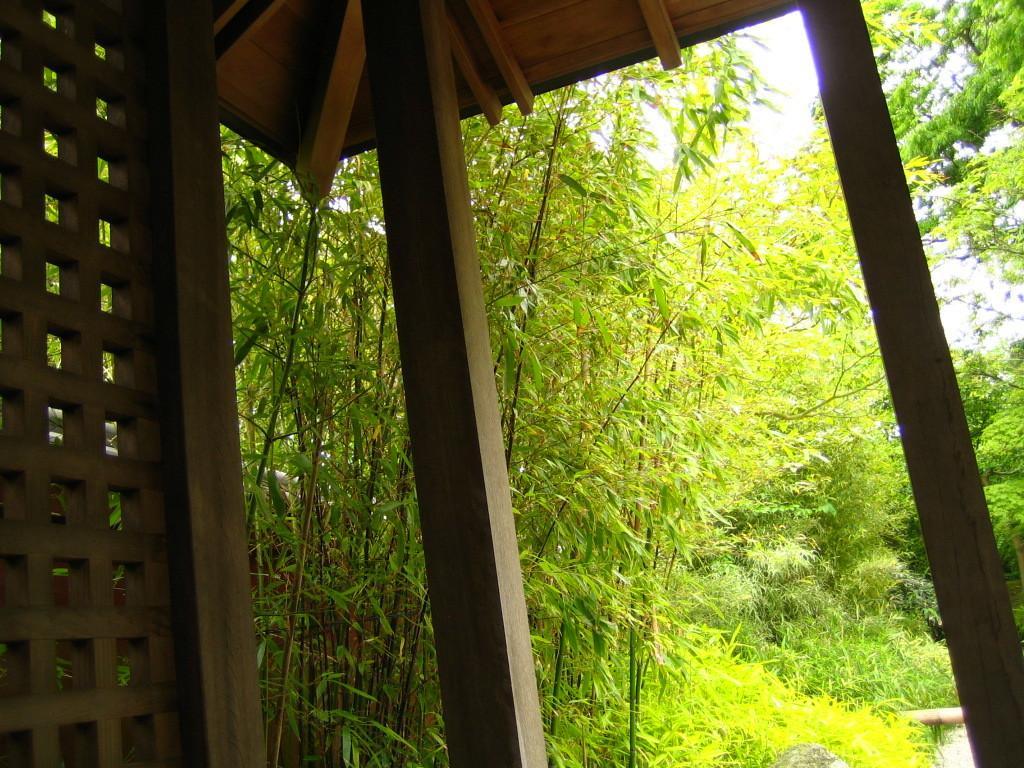Please provide a concise description of this image. In this picture I can see trees and few plants and I can see a wooden shelter. 